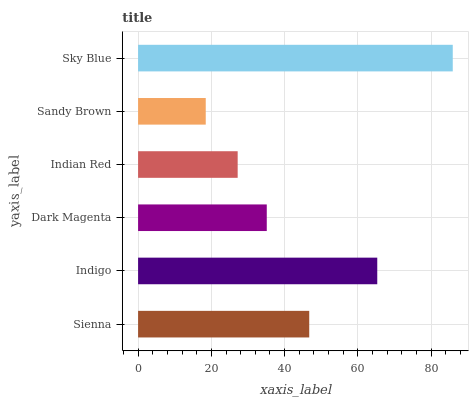Is Sandy Brown the minimum?
Answer yes or no. Yes. Is Sky Blue the maximum?
Answer yes or no. Yes. Is Indigo the minimum?
Answer yes or no. No. Is Indigo the maximum?
Answer yes or no. No. Is Indigo greater than Sienna?
Answer yes or no. Yes. Is Sienna less than Indigo?
Answer yes or no. Yes. Is Sienna greater than Indigo?
Answer yes or no. No. Is Indigo less than Sienna?
Answer yes or no. No. Is Sienna the high median?
Answer yes or no. Yes. Is Dark Magenta the low median?
Answer yes or no. Yes. Is Indigo the high median?
Answer yes or no. No. Is Sienna the low median?
Answer yes or no. No. 